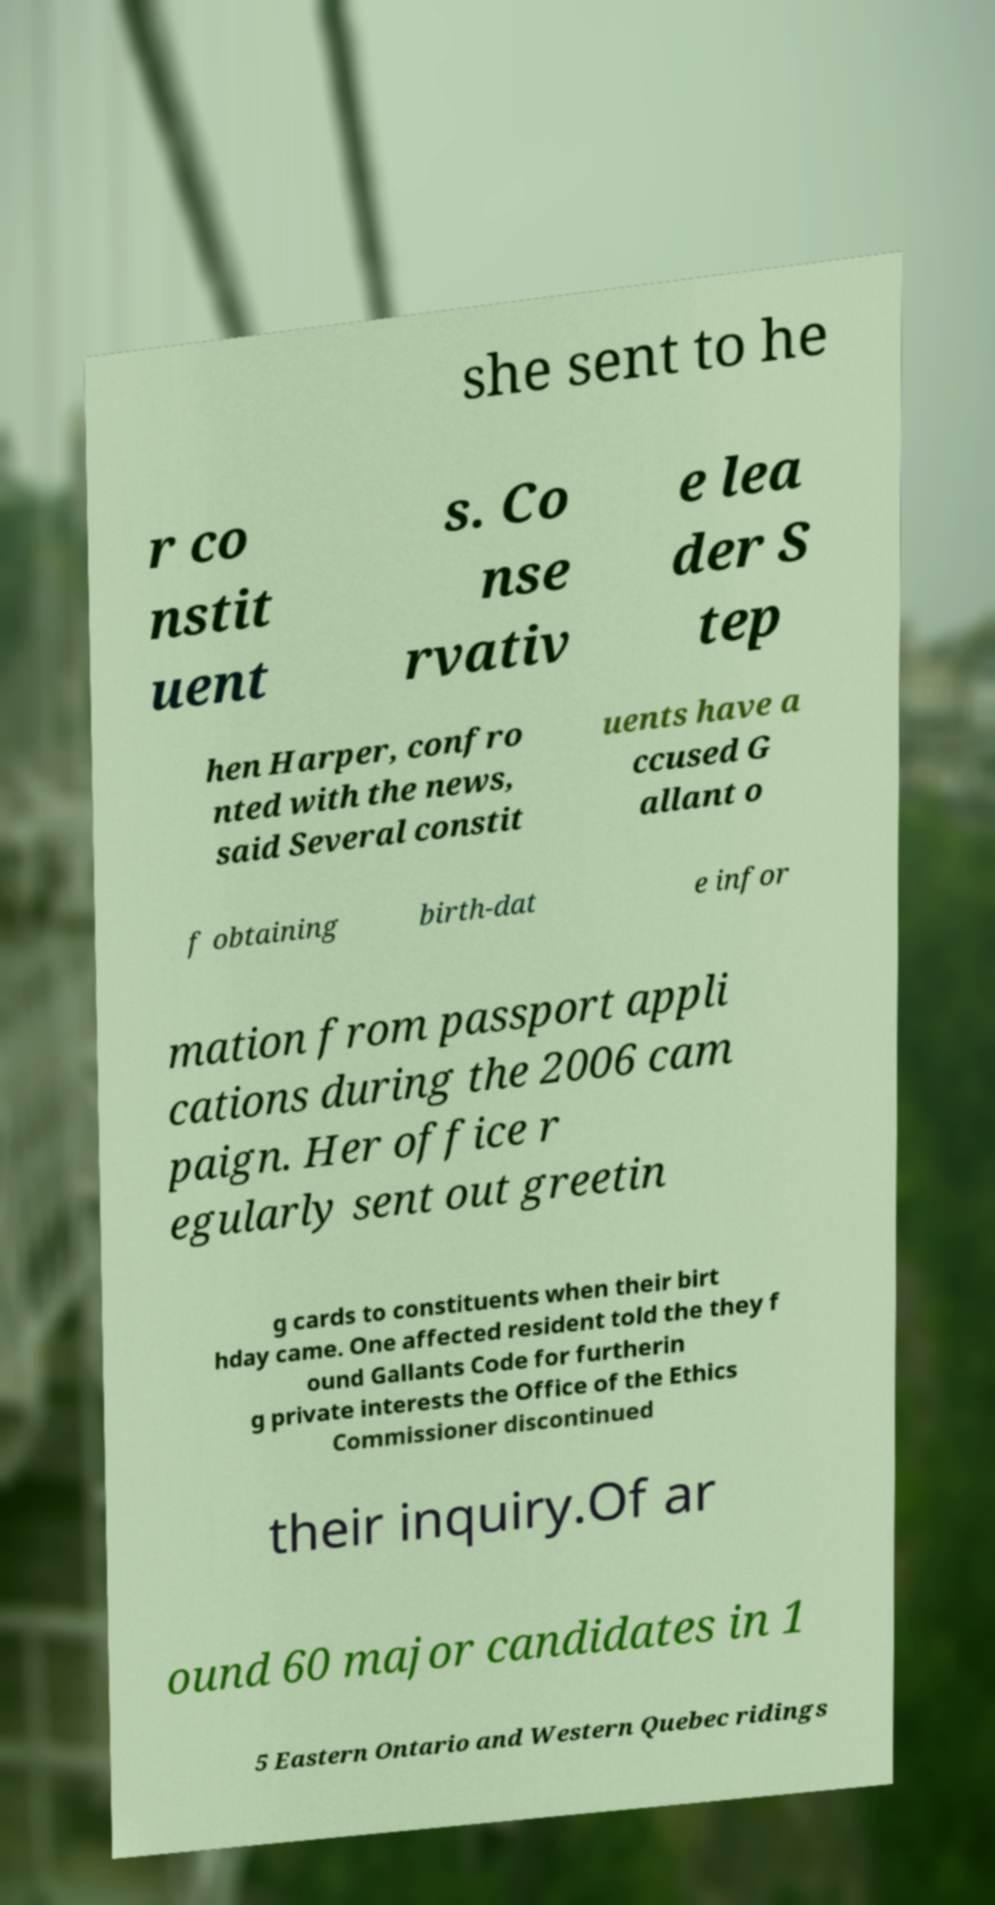There's text embedded in this image that I need extracted. Can you transcribe it verbatim? she sent to he r co nstit uent s. Co nse rvativ e lea der S tep hen Harper, confro nted with the news, said Several constit uents have a ccused G allant o f obtaining birth-dat e infor mation from passport appli cations during the 2006 cam paign. Her office r egularly sent out greetin g cards to constituents when their birt hday came. One affected resident told the they f ound Gallants Code for furtherin g private interests the Office of the Ethics Commissioner discontinued their inquiry.Of ar ound 60 major candidates in 1 5 Eastern Ontario and Western Quebec ridings 